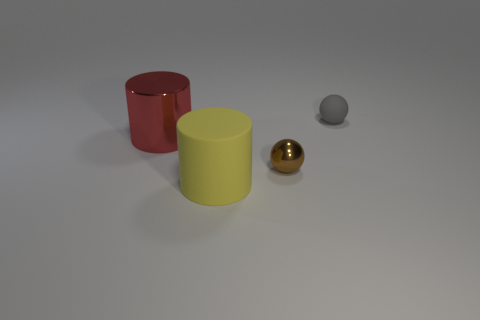What is the shape of the tiny thing that is in front of the tiny gray matte thing?
Offer a very short reply. Sphere. There is a matte thing that is behind the big cylinder that is behind the small brown metal ball; what color is it?
Offer a terse response. Gray. Do the big thing in front of the brown metal thing and the large shiny thing in front of the small rubber thing have the same shape?
Your answer should be compact. Yes. There is a shiny object that is the same size as the gray matte object; what shape is it?
Offer a terse response. Sphere. There is a object that is made of the same material as the large red cylinder; what color is it?
Provide a short and direct response. Brown. Is the shape of the tiny gray matte object the same as the shiny object that is right of the big yellow matte thing?
Your answer should be compact. Yes. There is a brown ball that is the same size as the gray ball; what is its material?
Provide a succinct answer. Metal. There is a thing that is both on the left side of the small brown thing and right of the metal cylinder; what shape is it?
Offer a terse response. Cylinder. How many red cylinders are the same material as the gray ball?
Give a very brief answer. 0. Is the number of big red cylinders on the right side of the large shiny thing less than the number of brown metal objects behind the large yellow rubber object?
Make the answer very short. Yes. 